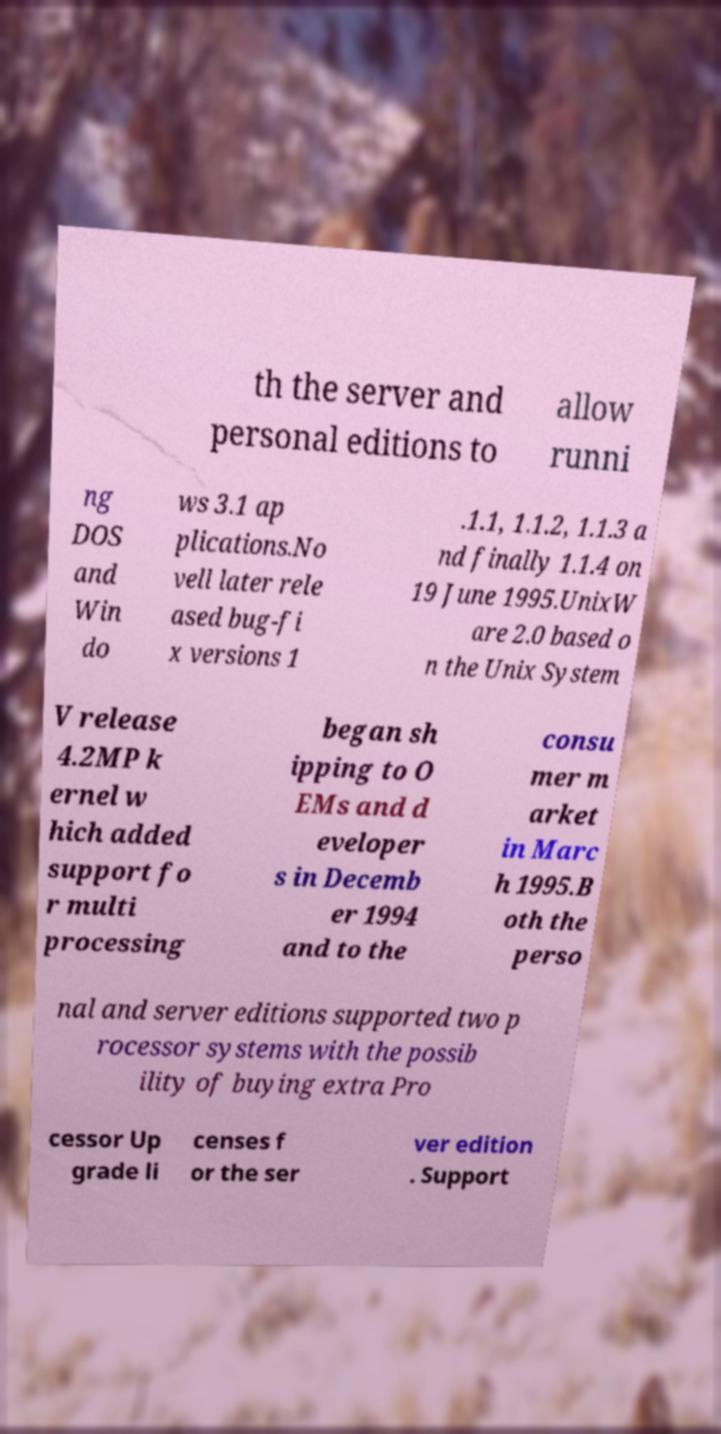Please read and relay the text visible in this image. What does it say? th the server and personal editions to allow runni ng DOS and Win do ws 3.1 ap plications.No vell later rele ased bug-fi x versions 1 .1.1, 1.1.2, 1.1.3 a nd finally 1.1.4 on 19 June 1995.UnixW are 2.0 based o n the Unix System V release 4.2MP k ernel w hich added support fo r multi processing began sh ipping to O EMs and d eveloper s in Decemb er 1994 and to the consu mer m arket in Marc h 1995.B oth the perso nal and server editions supported two p rocessor systems with the possib ility of buying extra Pro cessor Up grade li censes f or the ser ver edition . Support 